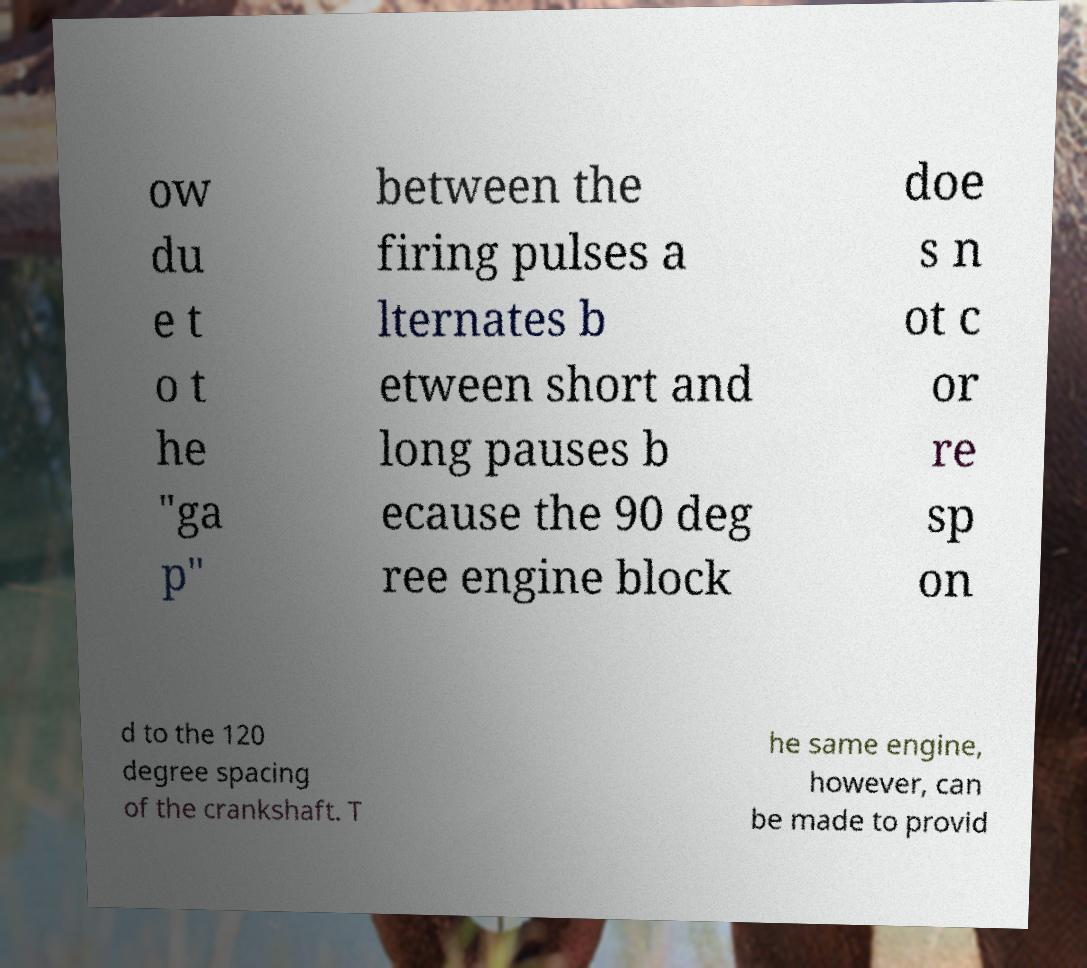There's text embedded in this image that I need extracted. Can you transcribe it verbatim? ow du e t o t he "ga p" between the firing pulses a lternates b etween short and long pauses b ecause the 90 deg ree engine block doe s n ot c or re sp on d to the 120 degree spacing of the crankshaft. T he same engine, however, can be made to provid 